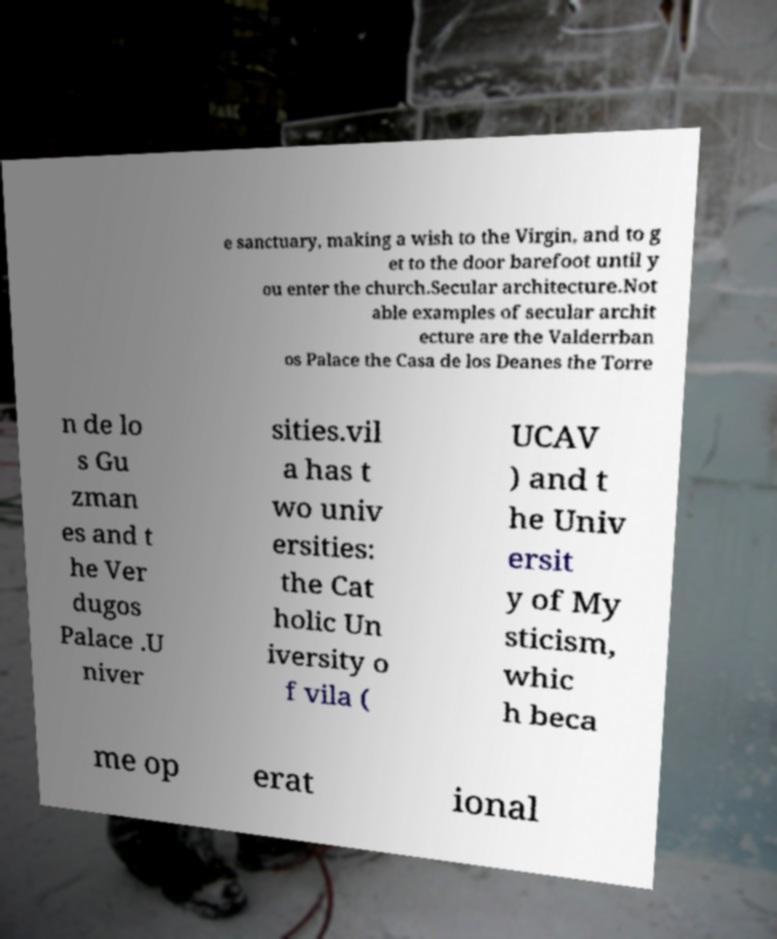Could you assist in decoding the text presented in this image and type it out clearly? e sanctuary, making a wish to the Virgin, and to g et to the door barefoot until y ou enter the church.Secular architecture.Not able examples of secular archit ecture are the Valderrban os Palace the Casa de los Deanes the Torre n de lo s Gu zman es and t he Ver dugos Palace .U niver sities.vil a has t wo univ ersities: the Cat holic Un iversity o f vila ( UCAV ) and t he Univ ersit y of My sticism, whic h beca me op erat ional 